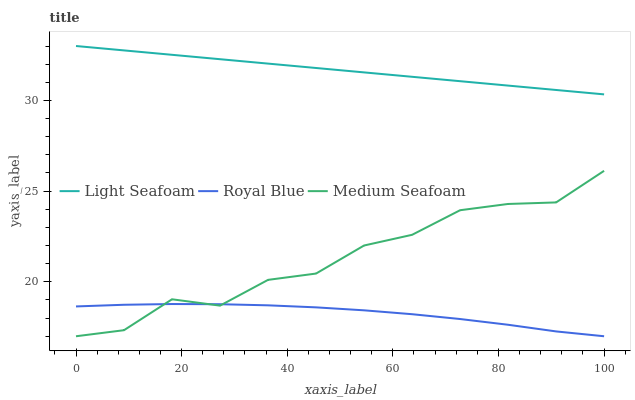Does Royal Blue have the minimum area under the curve?
Answer yes or no. Yes. Does Light Seafoam have the maximum area under the curve?
Answer yes or no. Yes. Does Medium Seafoam have the minimum area under the curve?
Answer yes or no. No. Does Medium Seafoam have the maximum area under the curve?
Answer yes or no. No. Is Light Seafoam the smoothest?
Answer yes or no. Yes. Is Medium Seafoam the roughest?
Answer yes or no. Yes. Is Medium Seafoam the smoothest?
Answer yes or no. No. Is Light Seafoam the roughest?
Answer yes or no. No. Does Royal Blue have the lowest value?
Answer yes or no. Yes. Does Light Seafoam have the lowest value?
Answer yes or no. No. Does Light Seafoam have the highest value?
Answer yes or no. Yes. Does Medium Seafoam have the highest value?
Answer yes or no. No. Is Royal Blue less than Light Seafoam?
Answer yes or no. Yes. Is Light Seafoam greater than Medium Seafoam?
Answer yes or no. Yes. Does Royal Blue intersect Medium Seafoam?
Answer yes or no. Yes. Is Royal Blue less than Medium Seafoam?
Answer yes or no. No. Is Royal Blue greater than Medium Seafoam?
Answer yes or no. No. Does Royal Blue intersect Light Seafoam?
Answer yes or no. No. 